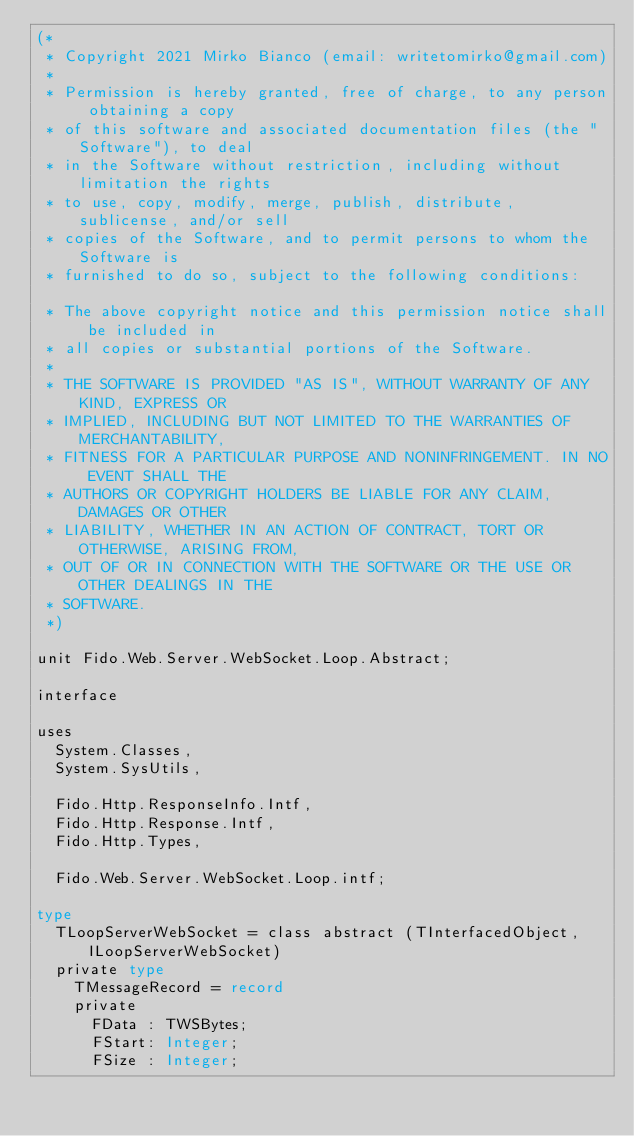Convert code to text. <code><loc_0><loc_0><loc_500><loc_500><_Pascal_>(*
 * Copyright 2021 Mirko Bianco (email: writetomirko@gmail.com)
 *
 * Permission is hereby granted, free of charge, to any person obtaining a copy
 * of this software and associated documentation files (the "Software"), to deal
 * in the Software without restriction, including without limitation the rights
 * to use, copy, modify, merge, publish, distribute, sublicense, and/or sell
 * copies of the Software, and to permit persons to whom the Software is
 * furnished to do so, subject to the following conditions:

 * The above copyright notice and this permission notice shall be included in
 * all copies or substantial portions of the Software.
 *
 * THE SOFTWARE IS PROVIDED "AS IS", WITHOUT WARRANTY OF ANY KIND, EXPRESS OR
 * IMPLIED, INCLUDING BUT NOT LIMITED TO THE WARRANTIES OF MERCHANTABILITY,
 * FITNESS FOR A PARTICULAR PURPOSE AND NONINFRINGEMENT. IN NO EVENT SHALL THE
 * AUTHORS OR COPYRIGHT HOLDERS BE LIABLE FOR ANY CLAIM, DAMAGES OR OTHER
 * LIABILITY, WHETHER IN AN ACTION OF CONTRACT, TORT OR OTHERWISE, ARISING FROM,
 * OUT OF OR IN CONNECTION WITH THE SOFTWARE OR THE USE OR OTHER DEALINGS IN THE
 * SOFTWARE.
 *)

unit Fido.Web.Server.WebSocket.Loop.Abstract;

interface

uses
  System.Classes,
  System.SysUtils,

  Fido.Http.ResponseInfo.Intf,
  Fido.Http.Response.Intf,
  Fido.Http.Types,

  Fido.Web.Server.WebSocket.Loop.intf;

type
  TLoopServerWebSocket = class abstract (TInterfacedObject, ILoopServerWebSocket)
  private type
    TMessageRecord = record
    private
      FData : TWSBytes;
      FStart: Integer;
      FSize : Integer;</code> 